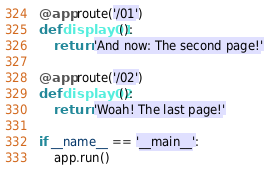<code> <loc_0><loc_0><loc_500><loc_500><_Python_>
@app.route('/01')
def display01():
    return 'And now: The second page!'

@app.route('/02')
def display02():
    return 'Woah! The last page!'

if __name__ == '__main__':
    app.run()
</code> 